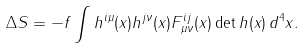Convert formula to latex. <formula><loc_0><loc_0><loc_500><loc_500>\Delta S = - f \int h ^ { i \mu } ( x ) h ^ { j \nu } ( x ) F ^ { i j } _ { \mu \nu } ( x ) \det h ( x ) \, d ^ { 4 } x .</formula> 